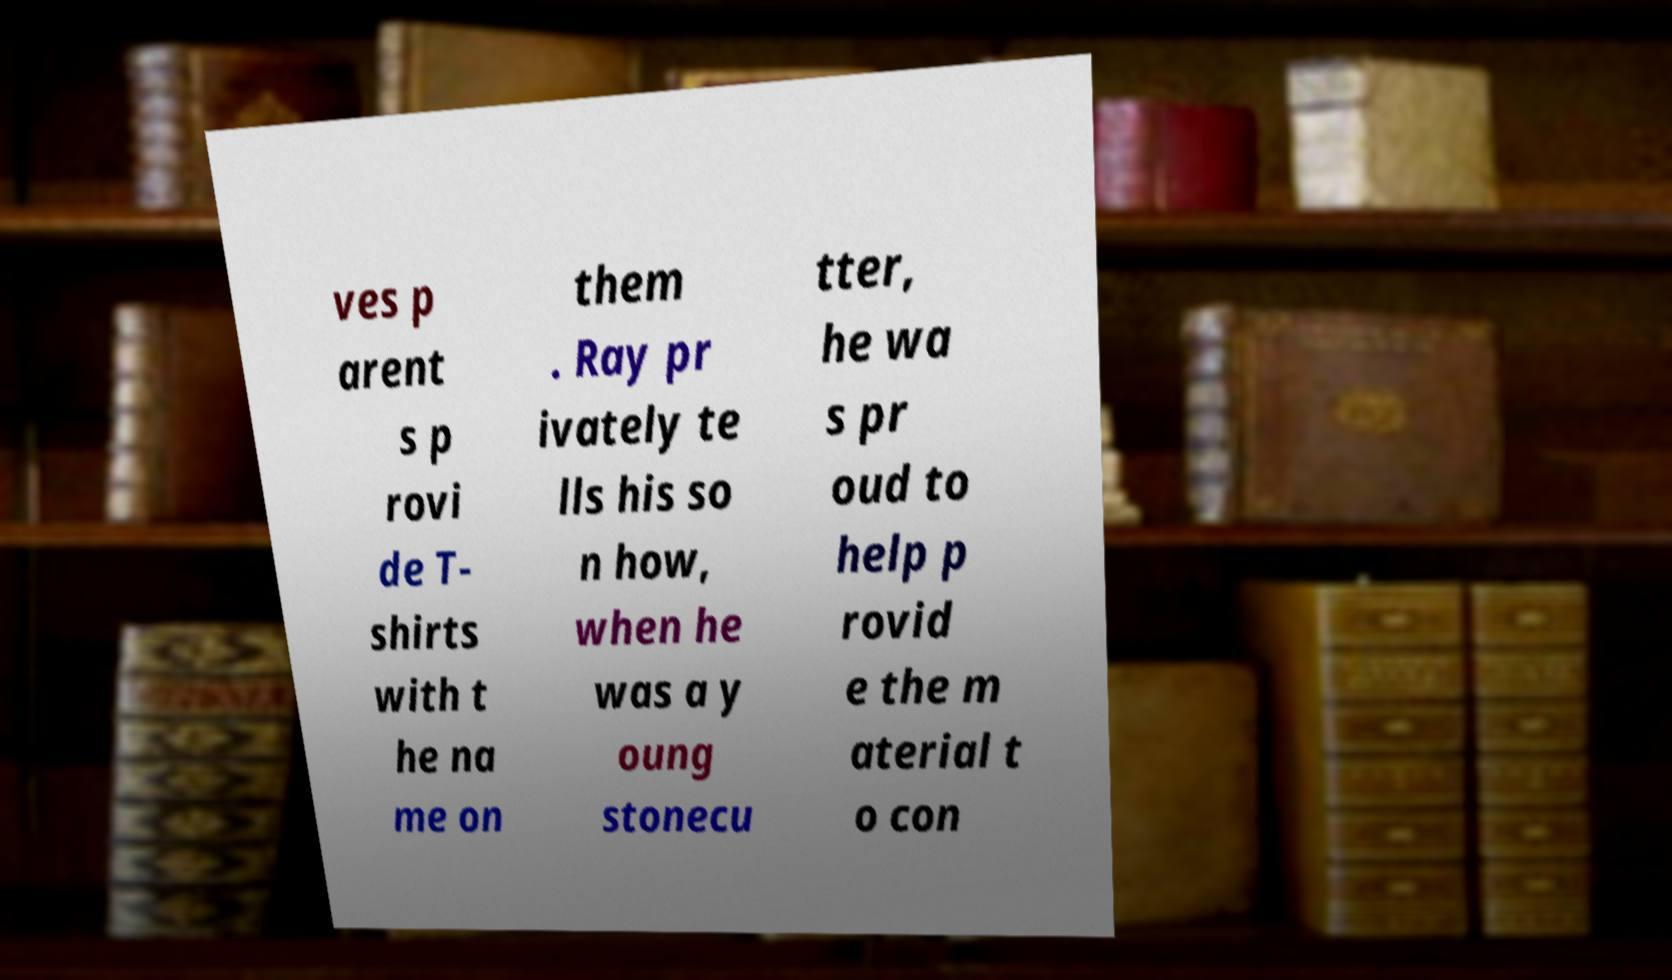For documentation purposes, I need the text within this image transcribed. Could you provide that? ves p arent s p rovi de T- shirts with t he na me on them . Ray pr ivately te lls his so n how, when he was a y oung stonecu tter, he wa s pr oud to help p rovid e the m aterial t o con 